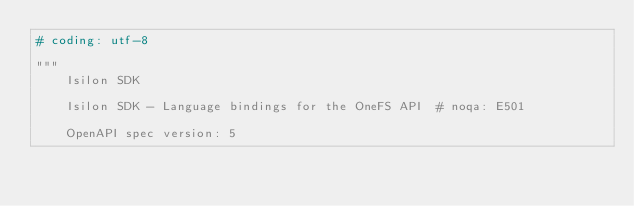Convert code to text. <code><loc_0><loc_0><loc_500><loc_500><_Python_># coding: utf-8

"""
    Isilon SDK

    Isilon SDK - Language bindings for the OneFS API  # noqa: E501

    OpenAPI spec version: 5</code> 